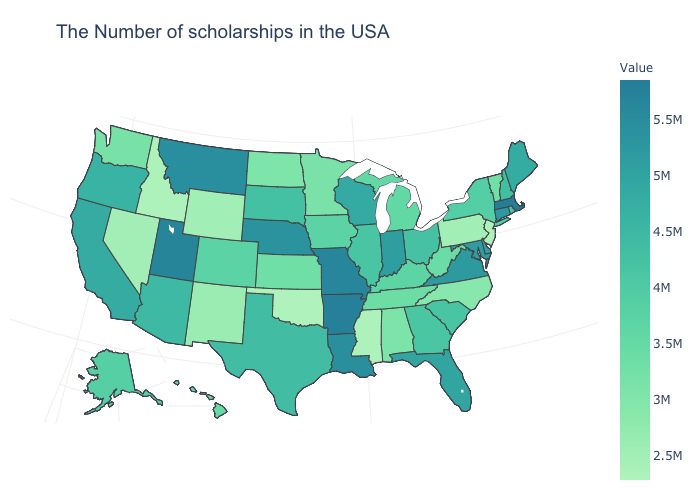Which states have the highest value in the USA?
Give a very brief answer. Massachusetts. Among the states that border Georgia , does North Carolina have the lowest value?
Answer briefly. Yes. Among the states that border New Mexico , does Arizona have the highest value?
Answer briefly. No. Does the map have missing data?
Be succinct. No. Among the states that border Virginia , does Maryland have the highest value?
Give a very brief answer. Yes. Does Pennsylvania have a lower value than Florida?
Keep it brief. Yes. Among the states that border Illinois , which have the lowest value?
Give a very brief answer. Kentucky. Which states hav the highest value in the West?
Quick response, please. Utah. 